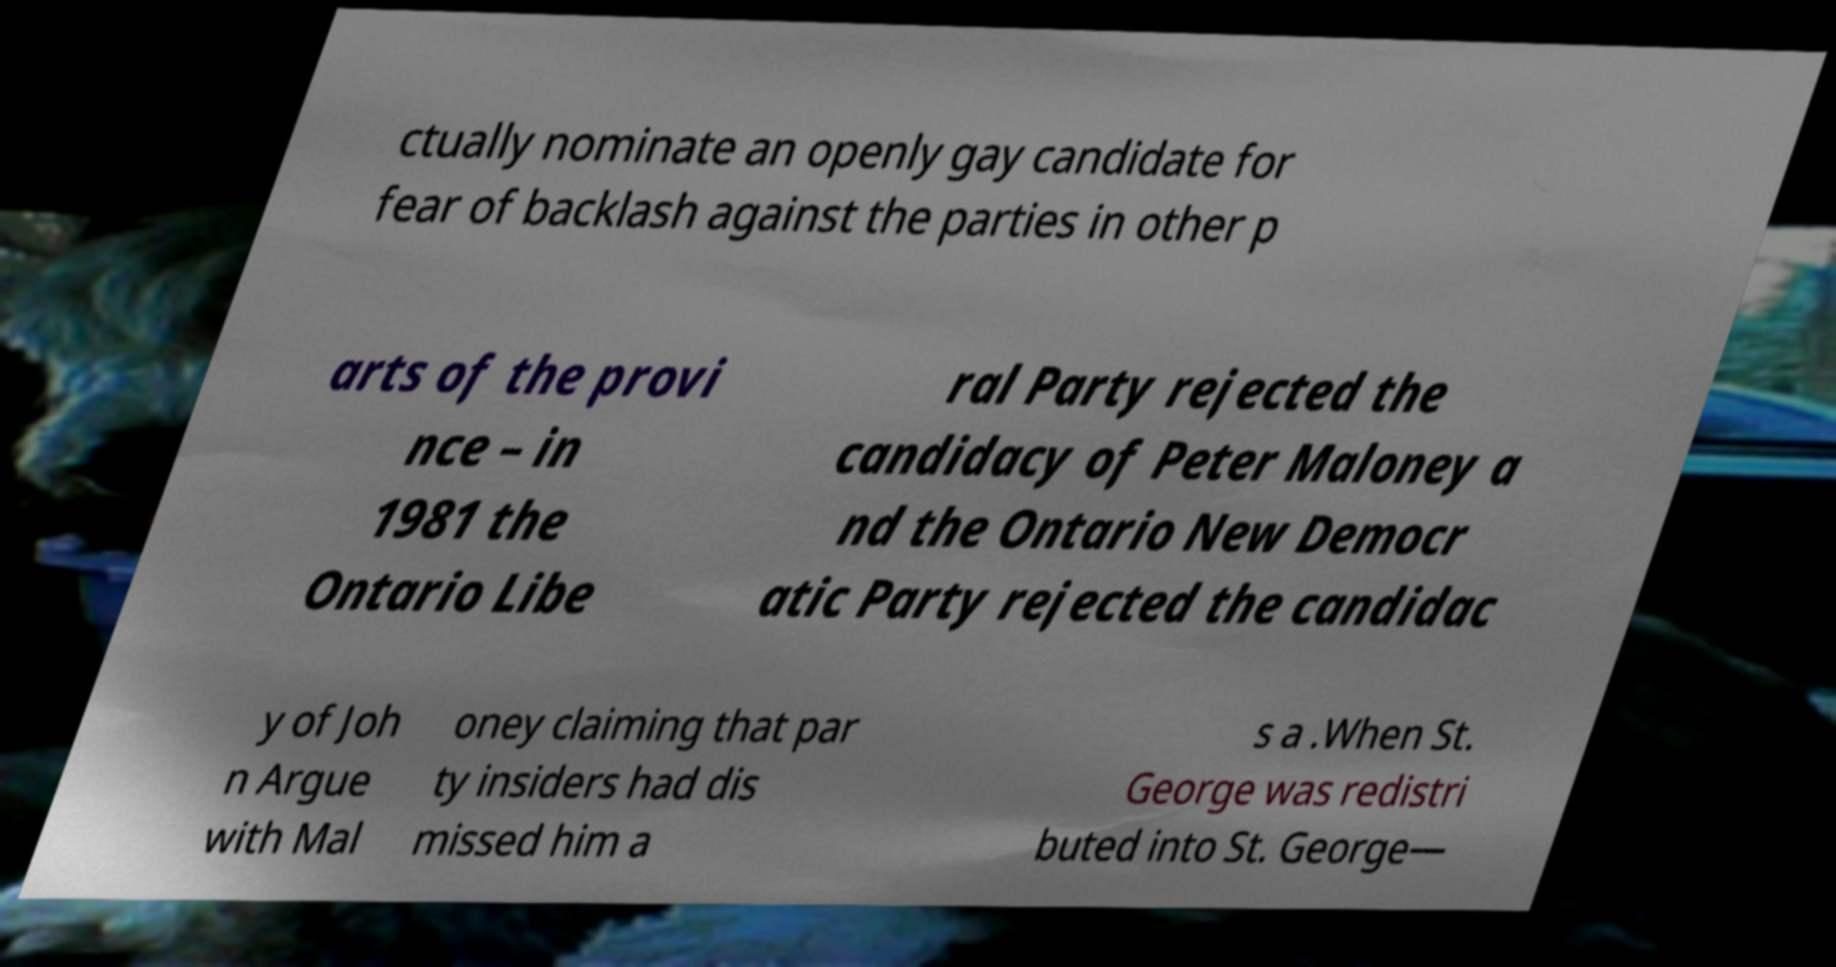Please identify and transcribe the text found in this image. ctually nominate an openly gay candidate for fear of backlash against the parties in other p arts of the provi nce – in 1981 the Ontario Libe ral Party rejected the candidacy of Peter Maloney a nd the Ontario New Democr atic Party rejected the candidac y of Joh n Argue with Mal oney claiming that par ty insiders had dis missed him a s a .When St. George was redistri buted into St. George— 